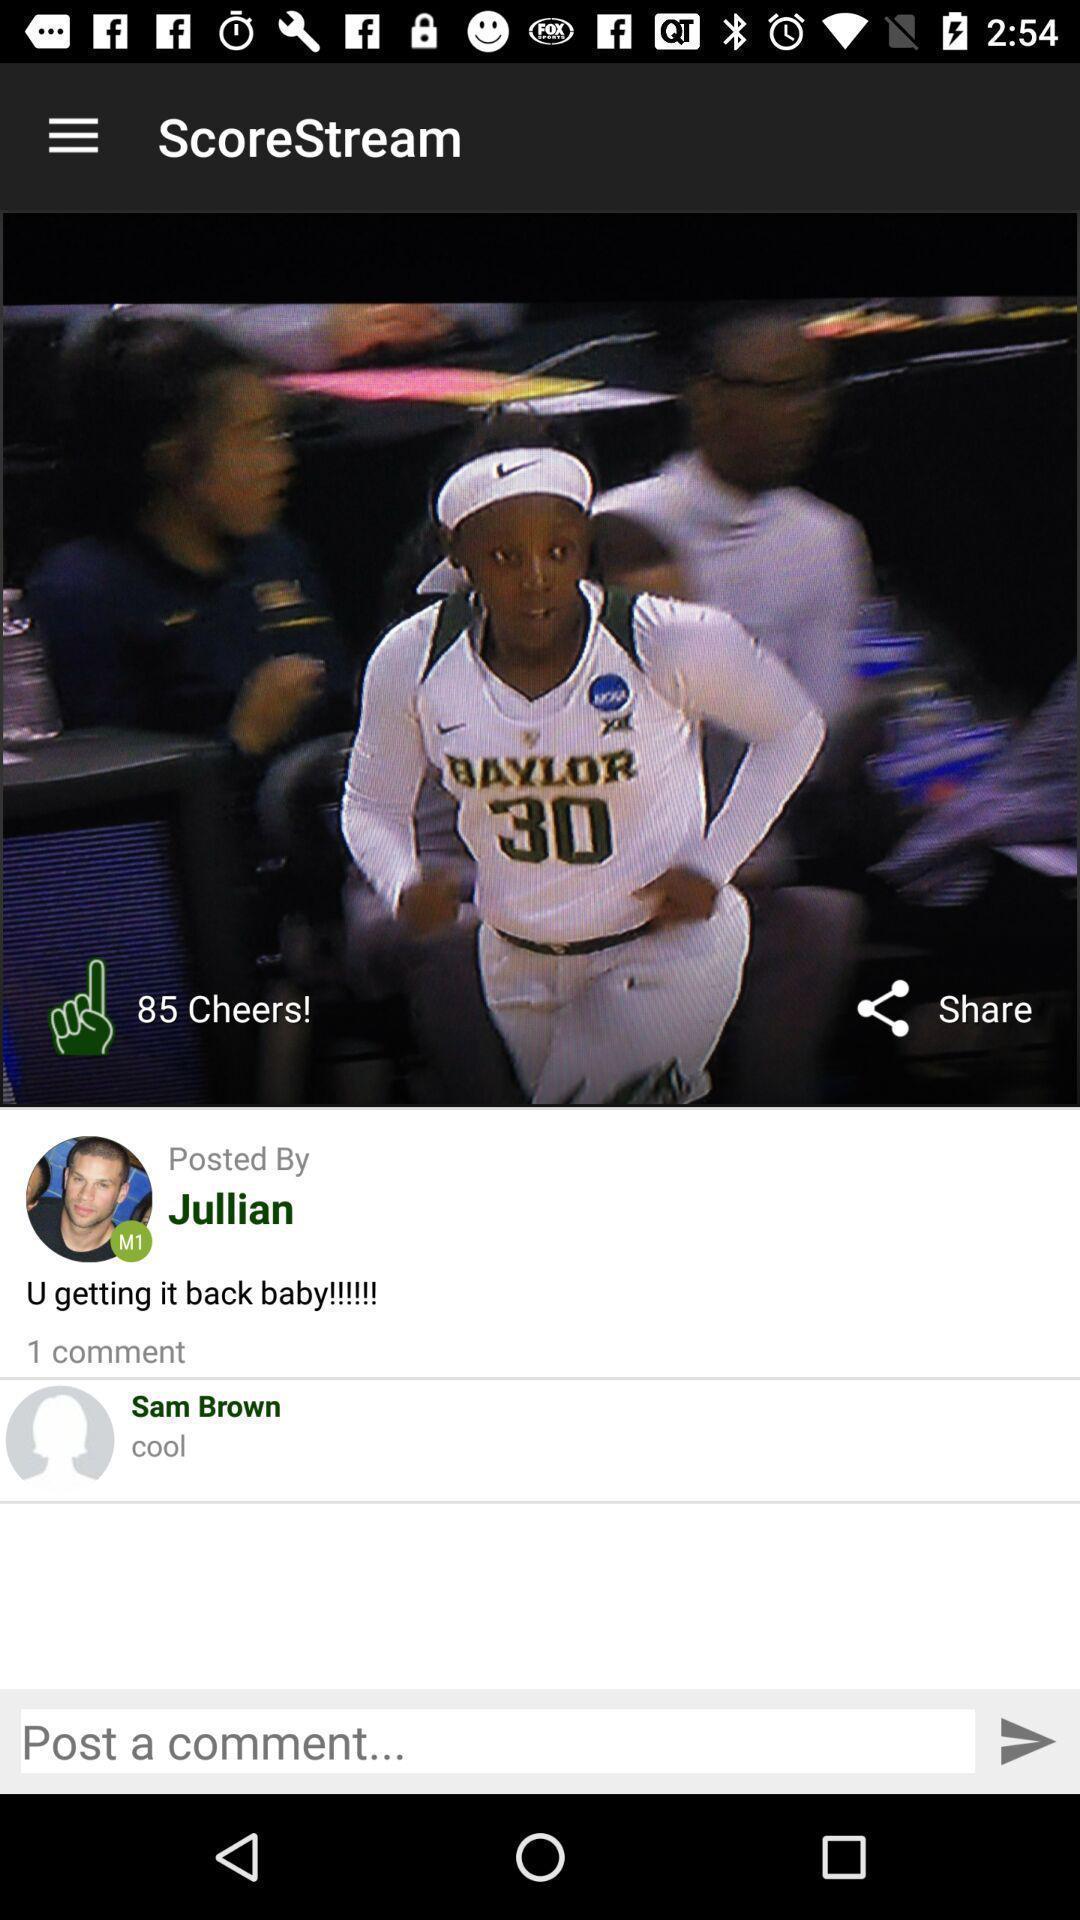Describe the key features of this screenshot. Screen shows score stream with multiple options. 